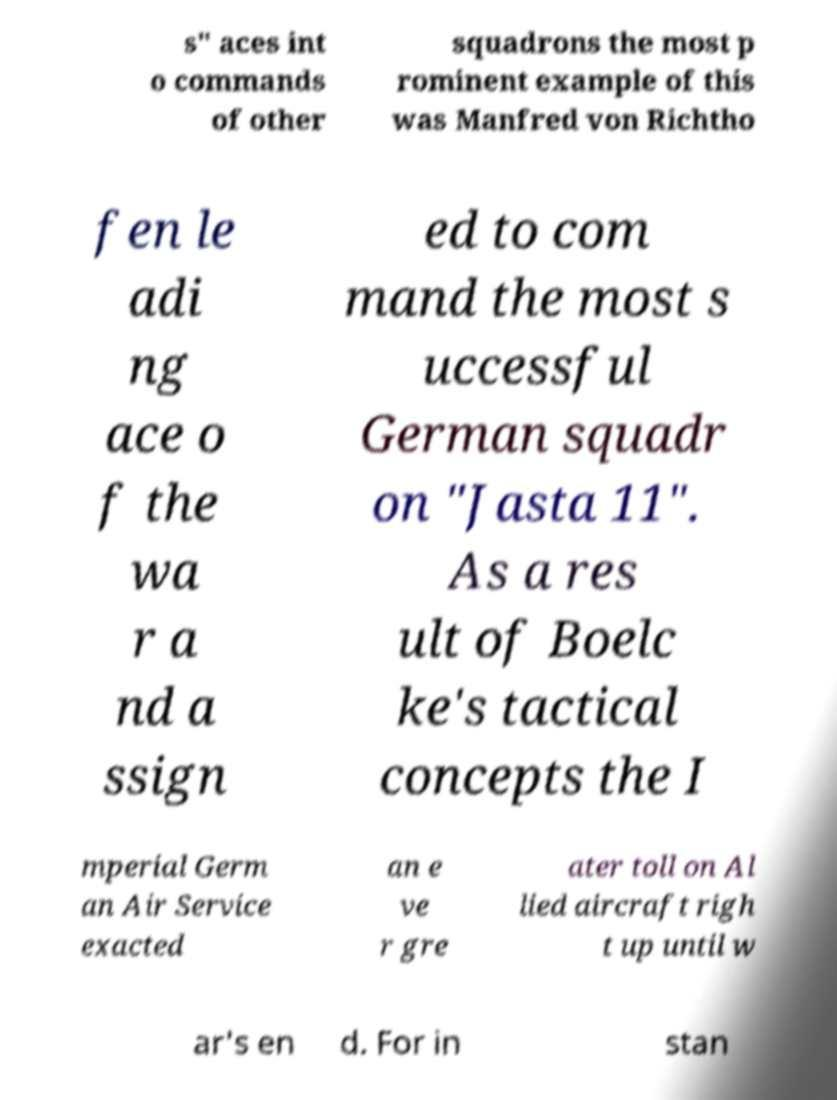Please identify and transcribe the text found in this image. s" aces int o commands of other squadrons the most p rominent example of this was Manfred von Richtho fen le adi ng ace o f the wa r a nd a ssign ed to com mand the most s uccessful German squadr on "Jasta 11". As a res ult of Boelc ke's tactical concepts the I mperial Germ an Air Service exacted an e ve r gre ater toll on Al lied aircraft righ t up until w ar's en d. For in stan 